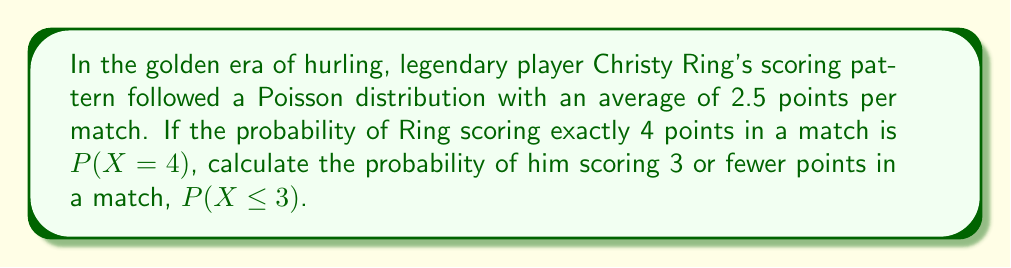Show me your answer to this math problem. Let's approach this step-by-step using statistical field theory:

1) The Poisson distribution is given by the formula:

   $$P(X=k) = \frac{e^{-\lambda}\lambda^k}{k!}$$

   where $\lambda$ is the average number of events in the interval, and $k$ is the number of events.

2) We're given that $\lambda = 2.5$ and we need to find $P(X \leq 3)$.

3) First, let's calculate $P(X=4)$:

   $$P(X=4) = \frac{e^{-2.5}2.5^4}{4!} \approx 0.1316$$

4) Now, we need to find $P(X \leq 3)$. This is equal to:

   $$P(X \leq 3) = P(X=0) + P(X=1) + P(X=2) + P(X=3)$$

5) Let's calculate each of these:

   $$P(X=0) = \frac{e^{-2.5}2.5^0}{0!} \approx 0.0821$$
   
   $$P(X=1) = \frac{e^{-2.5}2.5^1}{1!} \approx 0.2052$$
   
   $$P(X=2) = \frac{e^{-2.5}2.5^2}{2!} \approx 0.2565$$
   
   $$P(X=3) = \frac{e^{-2.5}2.5^3}{3!} \approx 0.2138$$

6) Adding these up:

   $$P(X \leq 3) = 0.0821 + 0.2052 + 0.2565 + 0.2138 = 0.7576$$

Therefore, the probability of Christy Ring scoring 3 or fewer points in a match is approximately 0.7576 or 75.76%.
Answer: 0.7576 